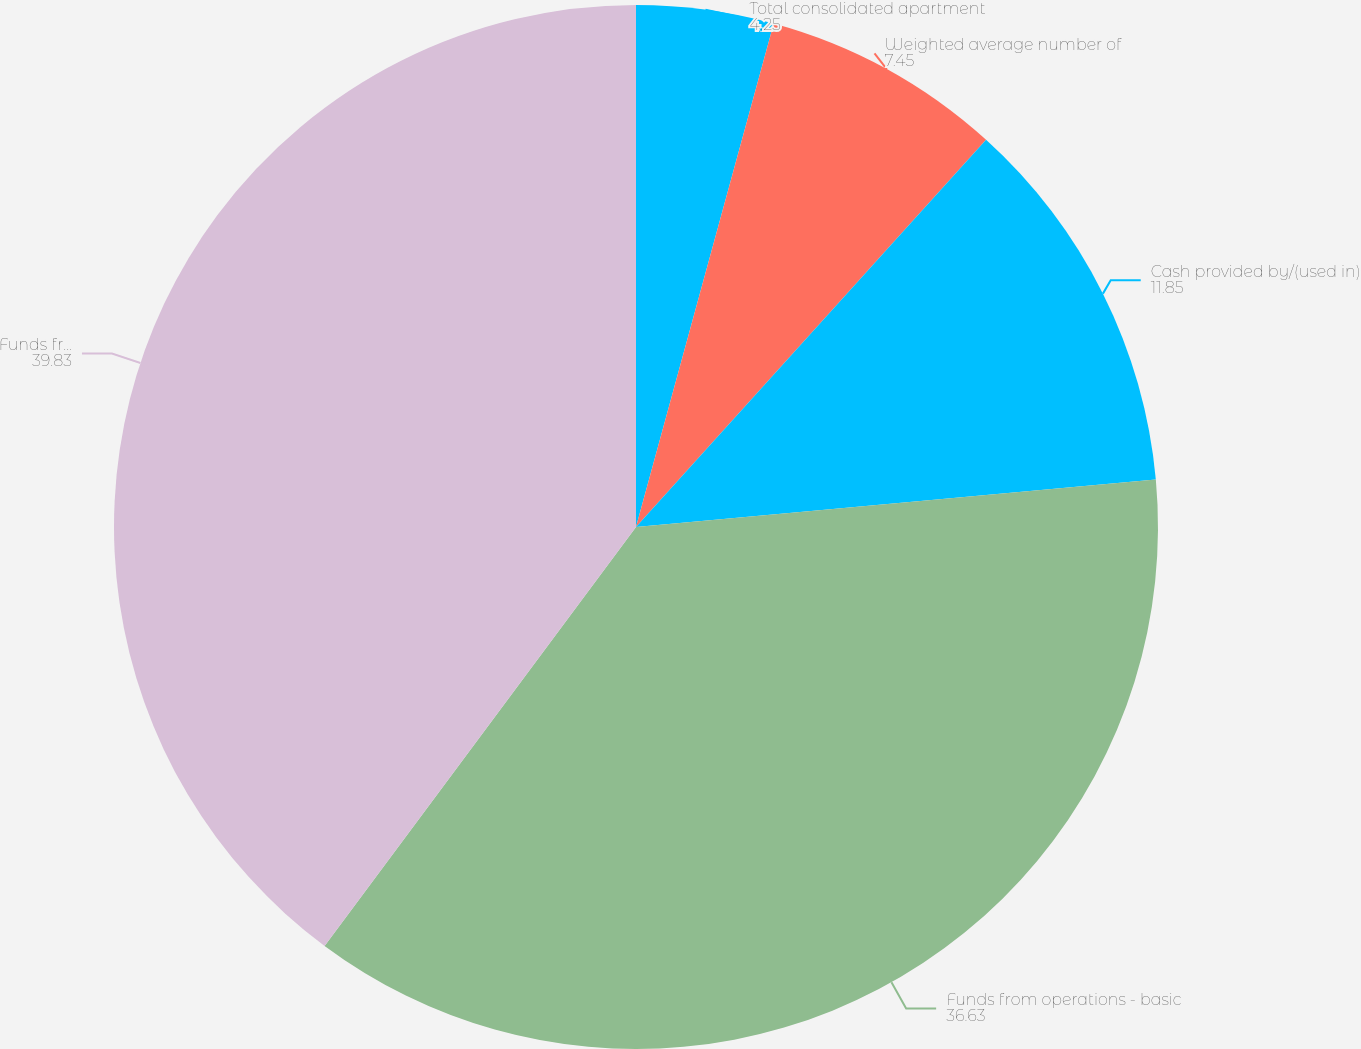Convert chart. <chart><loc_0><loc_0><loc_500><loc_500><pie_chart><fcel>Total consolidated apartment<fcel>Weighted average number of<fcel>Cash provided by/(used in)<fcel>Funds from operations - basic<fcel>Funds from operations -<nl><fcel>4.25%<fcel>7.45%<fcel>11.85%<fcel>36.63%<fcel>39.83%<nl></chart> 